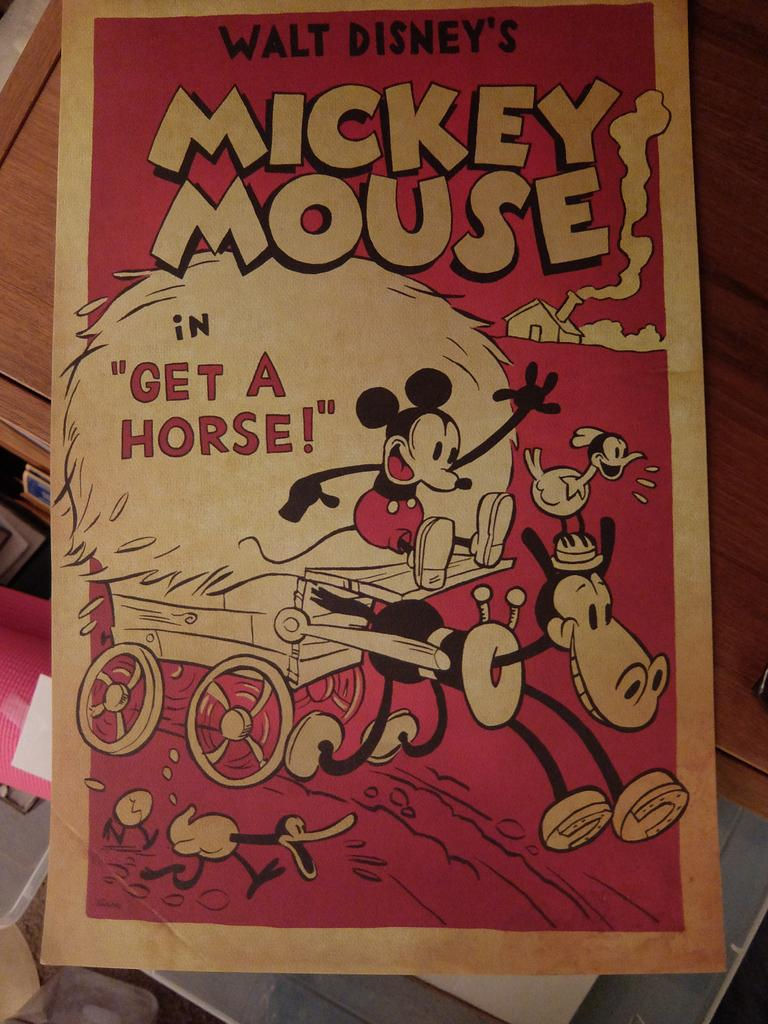<image>
Give a short and clear explanation of the subsequent image. A pamphlet for Mickey Mouse's "Get a Horse" short. 